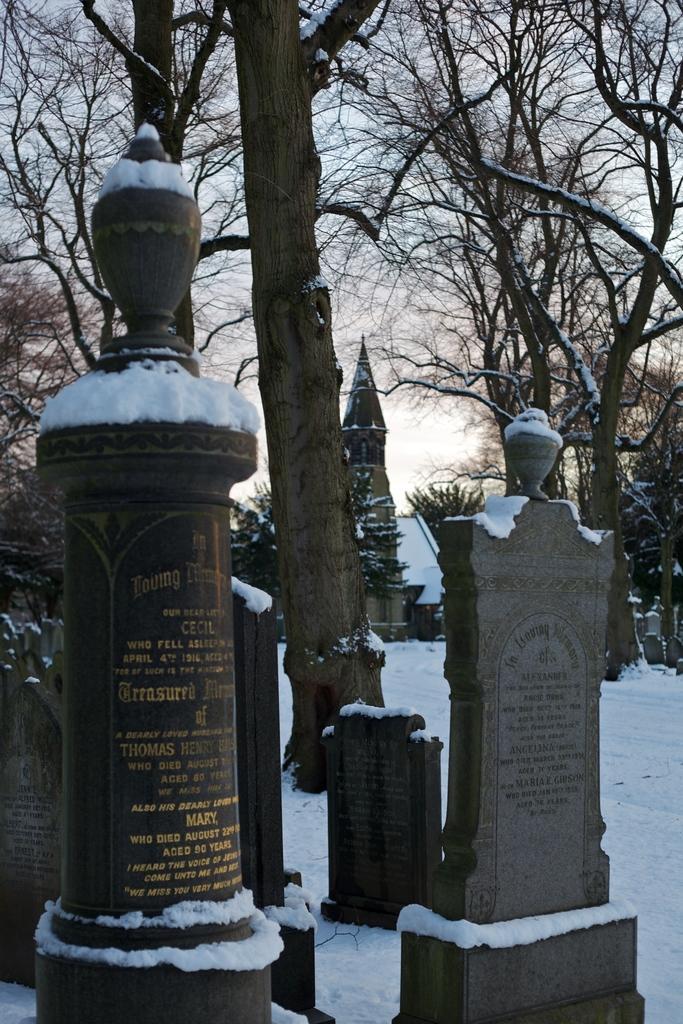In one or two sentences, can you explain what this image depicts? In this image we can see one building looks like a church, one white object near the church building, some grave stones with text, the ground is full of snow, some snow on the trees, some snow on the gravestones, some snow on the building, some trees on the ground and in the background there is the sky. 